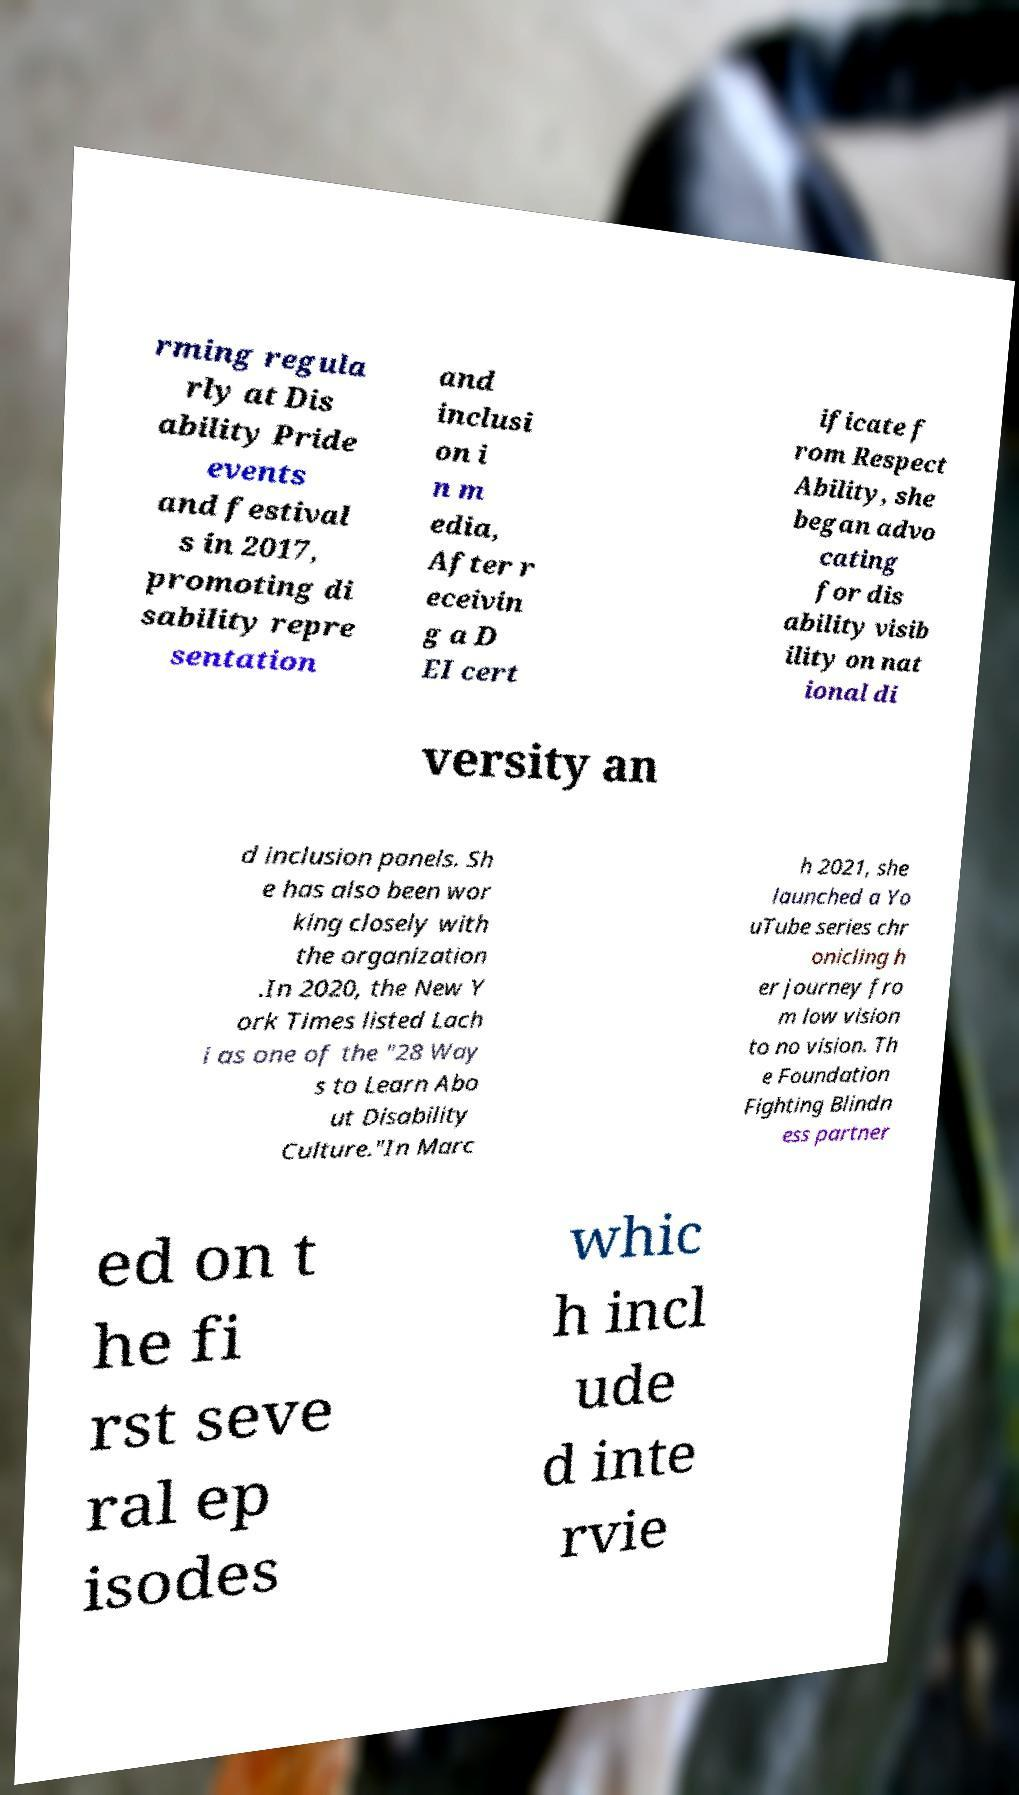Could you assist in decoding the text presented in this image and type it out clearly? rming regula rly at Dis ability Pride events and festival s in 2017, promoting di sability repre sentation and inclusi on i n m edia, After r eceivin g a D EI cert ificate f rom Respect Ability, she began advo cating for dis ability visib ility on nat ional di versity an d inclusion panels. Sh e has also been wor king closely with the organization .In 2020, the New Y ork Times listed Lach i as one of the "28 Way s to Learn Abo ut Disability Culture."In Marc h 2021, she launched a Yo uTube series chr onicling h er journey fro m low vision to no vision. Th e Foundation Fighting Blindn ess partner ed on t he fi rst seve ral ep isodes whic h incl ude d inte rvie 